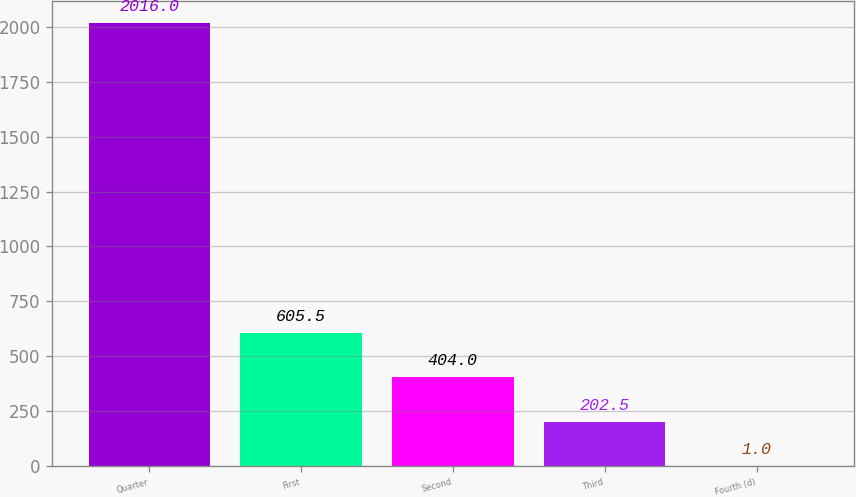Convert chart. <chart><loc_0><loc_0><loc_500><loc_500><bar_chart><fcel>Quarter<fcel>First<fcel>Second<fcel>Third<fcel>Fourth (d)<nl><fcel>2016<fcel>605.5<fcel>404<fcel>202.5<fcel>1<nl></chart> 